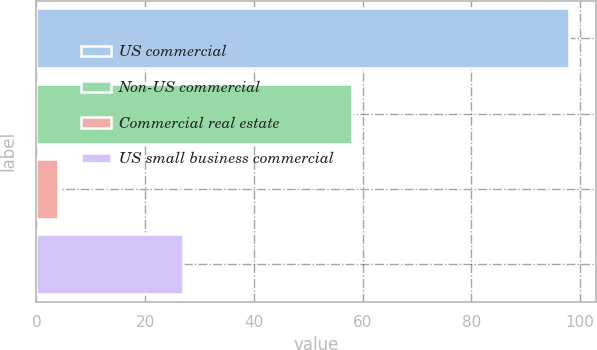Convert chart to OTSL. <chart><loc_0><loc_0><loc_500><loc_500><bar_chart><fcel>US commercial<fcel>Non-US commercial<fcel>Commercial real estate<fcel>US small business commercial<nl><fcel>98<fcel>58<fcel>4<fcel>27<nl></chart> 